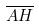<formula> <loc_0><loc_0><loc_500><loc_500>\overline { A H }</formula> 